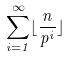<formula> <loc_0><loc_0><loc_500><loc_500>\sum _ { i = 1 } ^ { \infty } \lfloor \frac { n } { p ^ { i } } \rfloor</formula> 